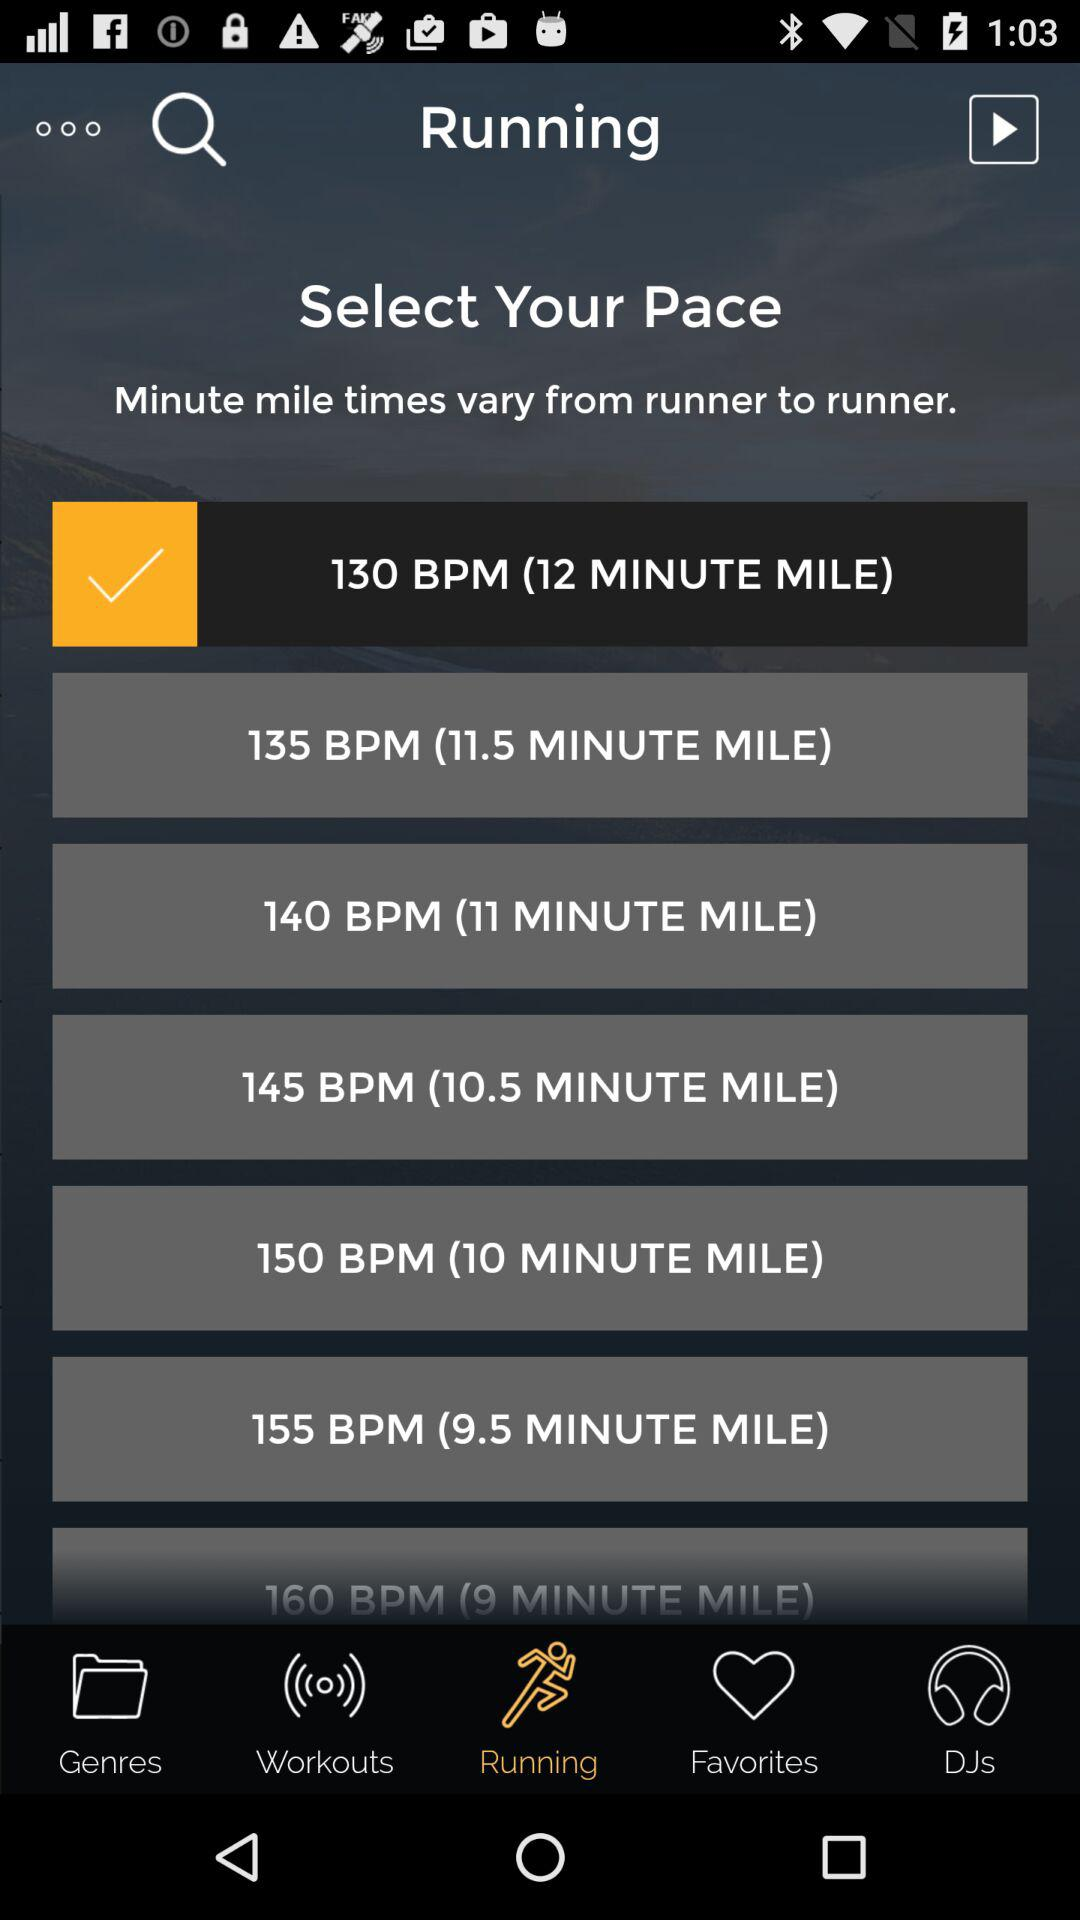Which option is selected? The selected options are "Running" and "130 BPM (12 MINUTE MILE)". 